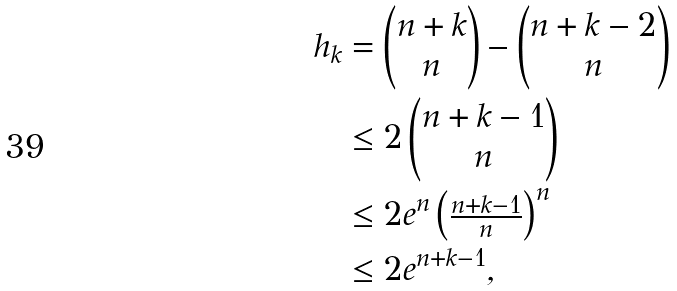Convert formula to latex. <formula><loc_0><loc_0><loc_500><loc_500>h _ { k } & = \begin{pmatrix} n + k \\ n \end{pmatrix} - \begin{pmatrix} n + k - 2 \\ n \end{pmatrix} \\ & \leq 2 \begin{pmatrix} n + k - 1 \\ n \end{pmatrix} \\ & \leq 2 e ^ { n } \begin{pmatrix} { \frac { n + k - 1 } n } \end{pmatrix} ^ { n } \\ & \leq 2 e ^ { n + k - 1 } ,</formula> 